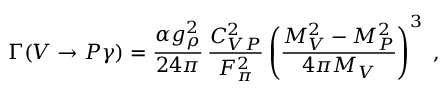Convert formula to latex. <formula><loc_0><loc_0><loc_500><loc_500>\Gamma ( V \rightarrow P \gamma ) = \frac { \alpha g _ { \rho } ^ { 2 } } { 2 4 \pi } \, \frac { C _ { V P } ^ { 2 } } { F _ { \pi } ^ { 2 } } \left ( \frac { M _ { V } ^ { 2 } - M _ { P } ^ { 2 } } { 4 \pi M _ { V } } \right ) ^ { 3 } \, ,</formula> 